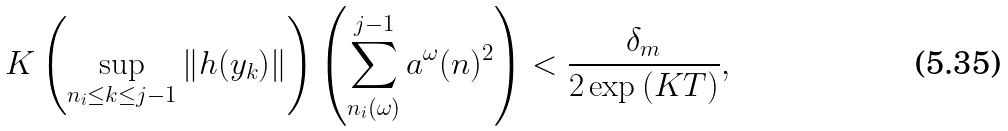Convert formula to latex. <formula><loc_0><loc_0><loc_500><loc_500>K \left ( \sup _ { n _ { i } \leq k \leq j - 1 } \| h ( y _ { k } ) \| \right ) \left ( \sum _ { n _ { i } ( \omega ) } ^ { j - 1 } a ^ { \omega } ( n ) ^ { 2 } \right ) < \frac { \delta _ { m } } { 2 \exp { ( K T ) } } ,</formula> 